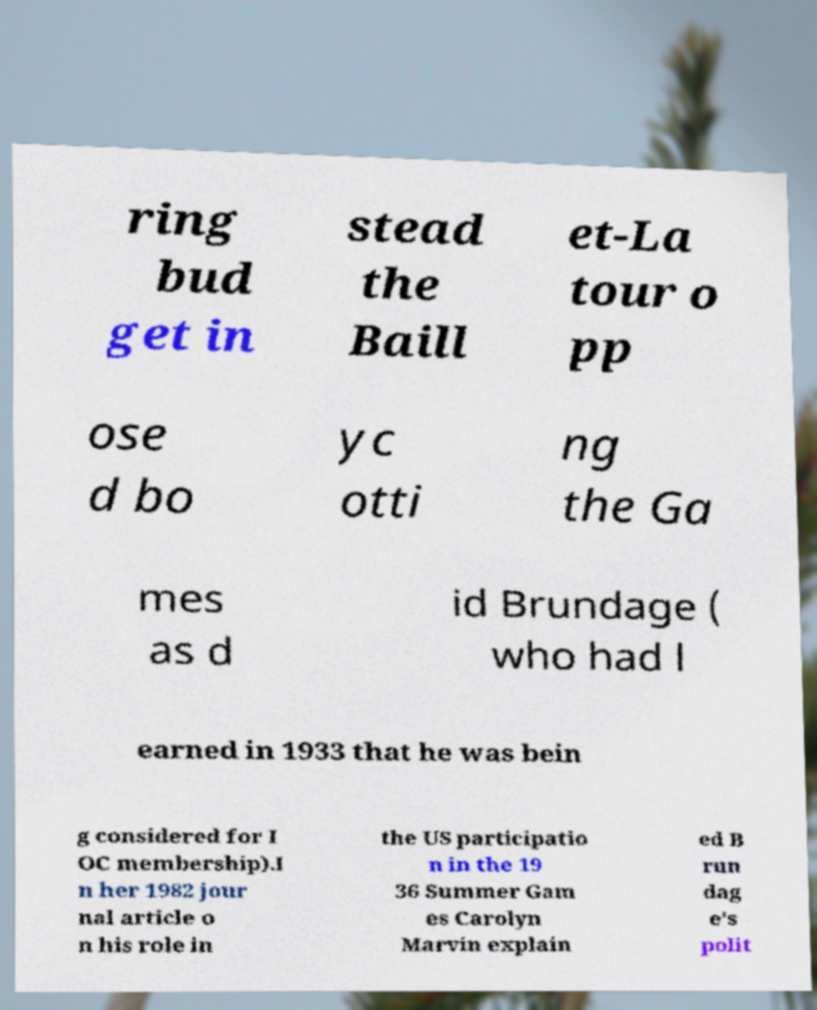Can you read and provide the text displayed in the image?This photo seems to have some interesting text. Can you extract and type it out for me? ring bud get in stead the Baill et-La tour o pp ose d bo yc otti ng the Ga mes as d id Brundage ( who had l earned in 1933 that he was bein g considered for I OC membership).I n her 1982 jour nal article o n his role in the US participatio n in the 19 36 Summer Gam es Carolyn Marvin explain ed B run dag e's polit 